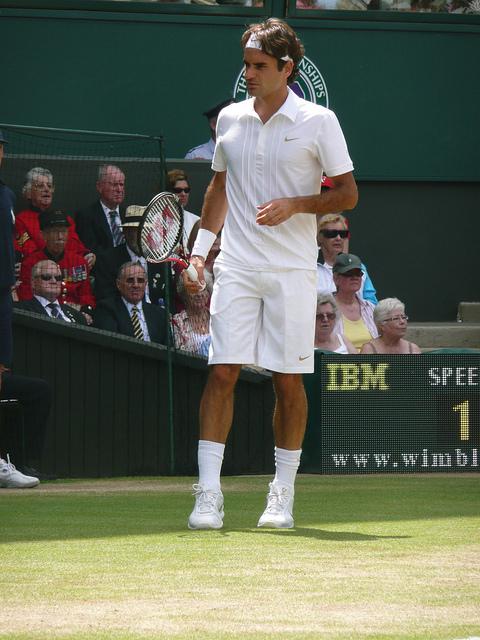What clothing color does the tennis player prefer?
Keep it brief. White. Is the player upset about something?
Write a very short answer. Yes. What is this player doing?
Concise answer only. Walking. 